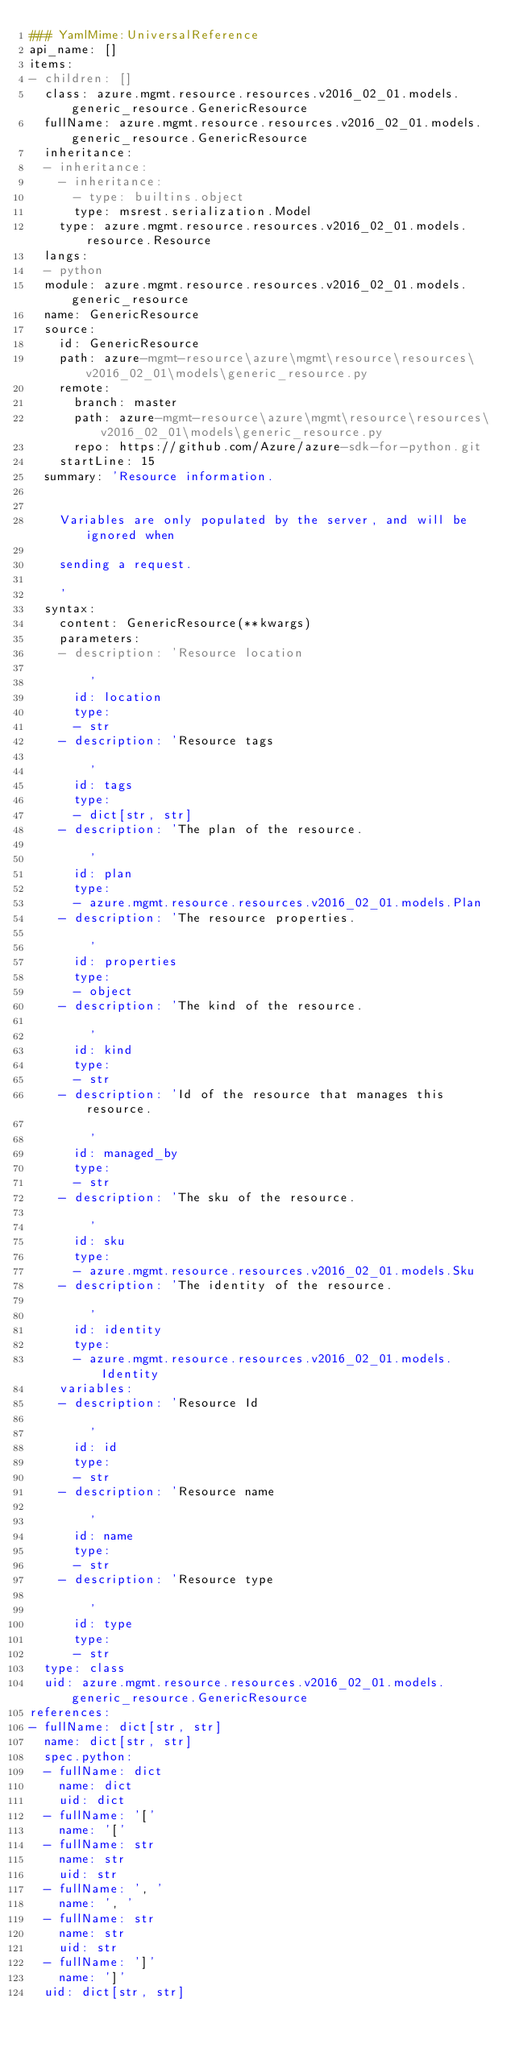<code> <loc_0><loc_0><loc_500><loc_500><_YAML_>### YamlMime:UniversalReference
api_name: []
items:
- children: []
  class: azure.mgmt.resource.resources.v2016_02_01.models.generic_resource.GenericResource
  fullName: azure.mgmt.resource.resources.v2016_02_01.models.generic_resource.GenericResource
  inheritance:
  - inheritance:
    - inheritance:
      - type: builtins.object
      type: msrest.serialization.Model
    type: azure.mgmt.resource.resources.v2016_02_01.models.resource.Resource
  langs:
  - python
  module: azure.mgmt.resource.resources.v2016_02_01.models.generic_resource
  name: GenericResource
  source:
    id: GenericResource
    path: azure-mgmt-resource\azure\mgmt\resource\resources\v2016_02_01\models\generic_resource.py
    remote:
      branch: master
      path: azure-mgmt-resource\azure\mgmt\resource\resources\v2016_02_01\models\generic_resource.py
      repo: https://github.com/Azure/azure-sdk-for-python.git
    startLine: 15
  summary: 'Resource information.


    Variables are only populated by the server, and will be ignored when

    sending a request.

    '
  syntax:
    content: GenericResource(**kwargs)
    parameters:
    - description: 'Resource location

        '
      id: location
      type:
      - str
    - description: 'Resource tags

        '
      id: tags
      type:
      - dict[str, str]
    - description: 'The plan of the resource.

        '
      id: plan
      type:
      - azure.mgmt.resource.resources.v2016_02_01.models.Plan
    - description: 'The resource properties.

        '
      id: properties
      type:
      - object
    - description: 'The kind of the resource.

        '
      id: kind
      type:
      - str
    - description: 'Id of the resource that manages this resource.

        '
      id: managed_by
      type:
      - str
    - description: 'The sku of the resource.

        '
      id: sku
      type:
      - azure.mgmt.resource.resources.v2016_02_01.models.Sku
    - description: 'The identity of the resource.

        '
      id: identity
      type:
      - azure.mgmt.resource.resources.v2016_02_01.models.Identity
    variables:
    - description: 'Resource Id

        '
      id: id
      type:
      - str
    - description: 'Resource name

        '
      id: name
      type:
      - str
    - description: 'Resource type

        '
      id: type
      type:
      - str
  type: class
  uid: azure.mgmt.resource.resources.v2016_02_01.models.generic_resource.GenericResource
references:
- fullName: dict[str, str]
  name: dict[str, str]
  spec.python:
  - fullName: dict
    name: dict
    uid: dict
  - fullName: '['
    name: '['
  - fullName: str
    name: str
    uid: str
  - fullName: ', '
    name: ', '
  - fullName: str
    name: str
    uid: str
  - fullName: ']'
    name: ']'
  uid: dict[str, str]
</code> 